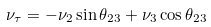<formula> <loc_0><loc_0><loc_500><loc_500>\nu _ { \tau } = - \nu _ { 2 } \sin \theta _ { 2 3 } + \nu _ { 3 } \cos \theta _ { 2 3 }</formula> 